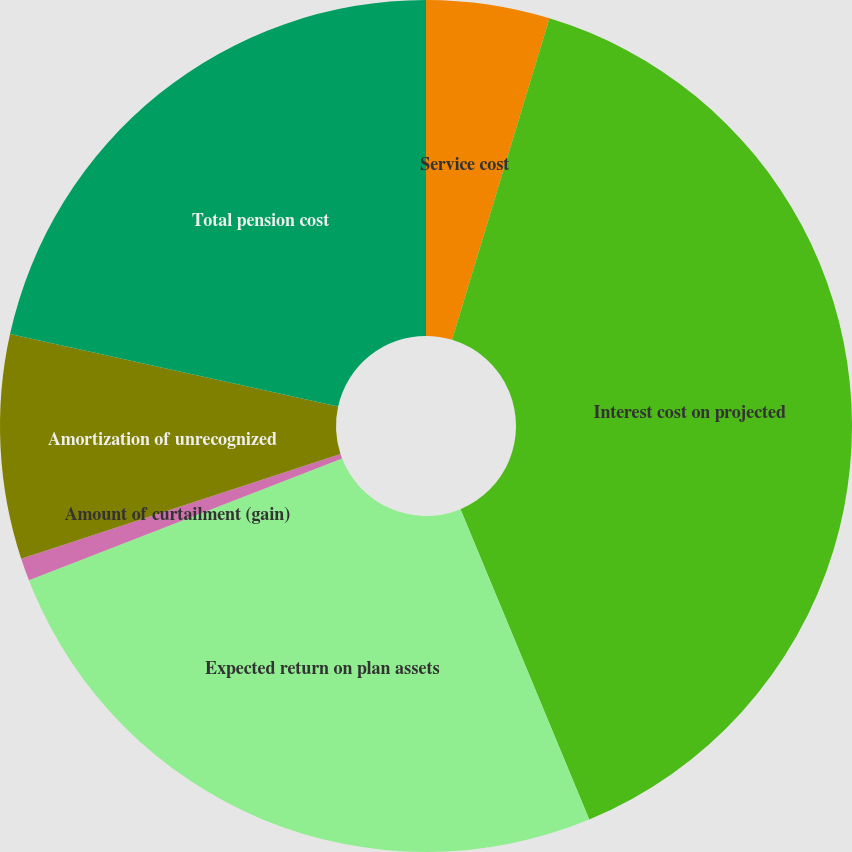<chart> <loc_0><loc_0><loc_500><loc_500><pie_chart><fcel>Service cost<fcel>Interest cost on projected<fcel>Expected return on plan assets<fcel>Amount of curtailment (gain)<fcel>Amortization of unrecognized<fcel>Total pension cost<nl><fcel>4.68%<fcel>39.06%<fcel>25.36%<fcel>0.86%<fcel>8.5%<fcel>21.54%<nl></chart> 